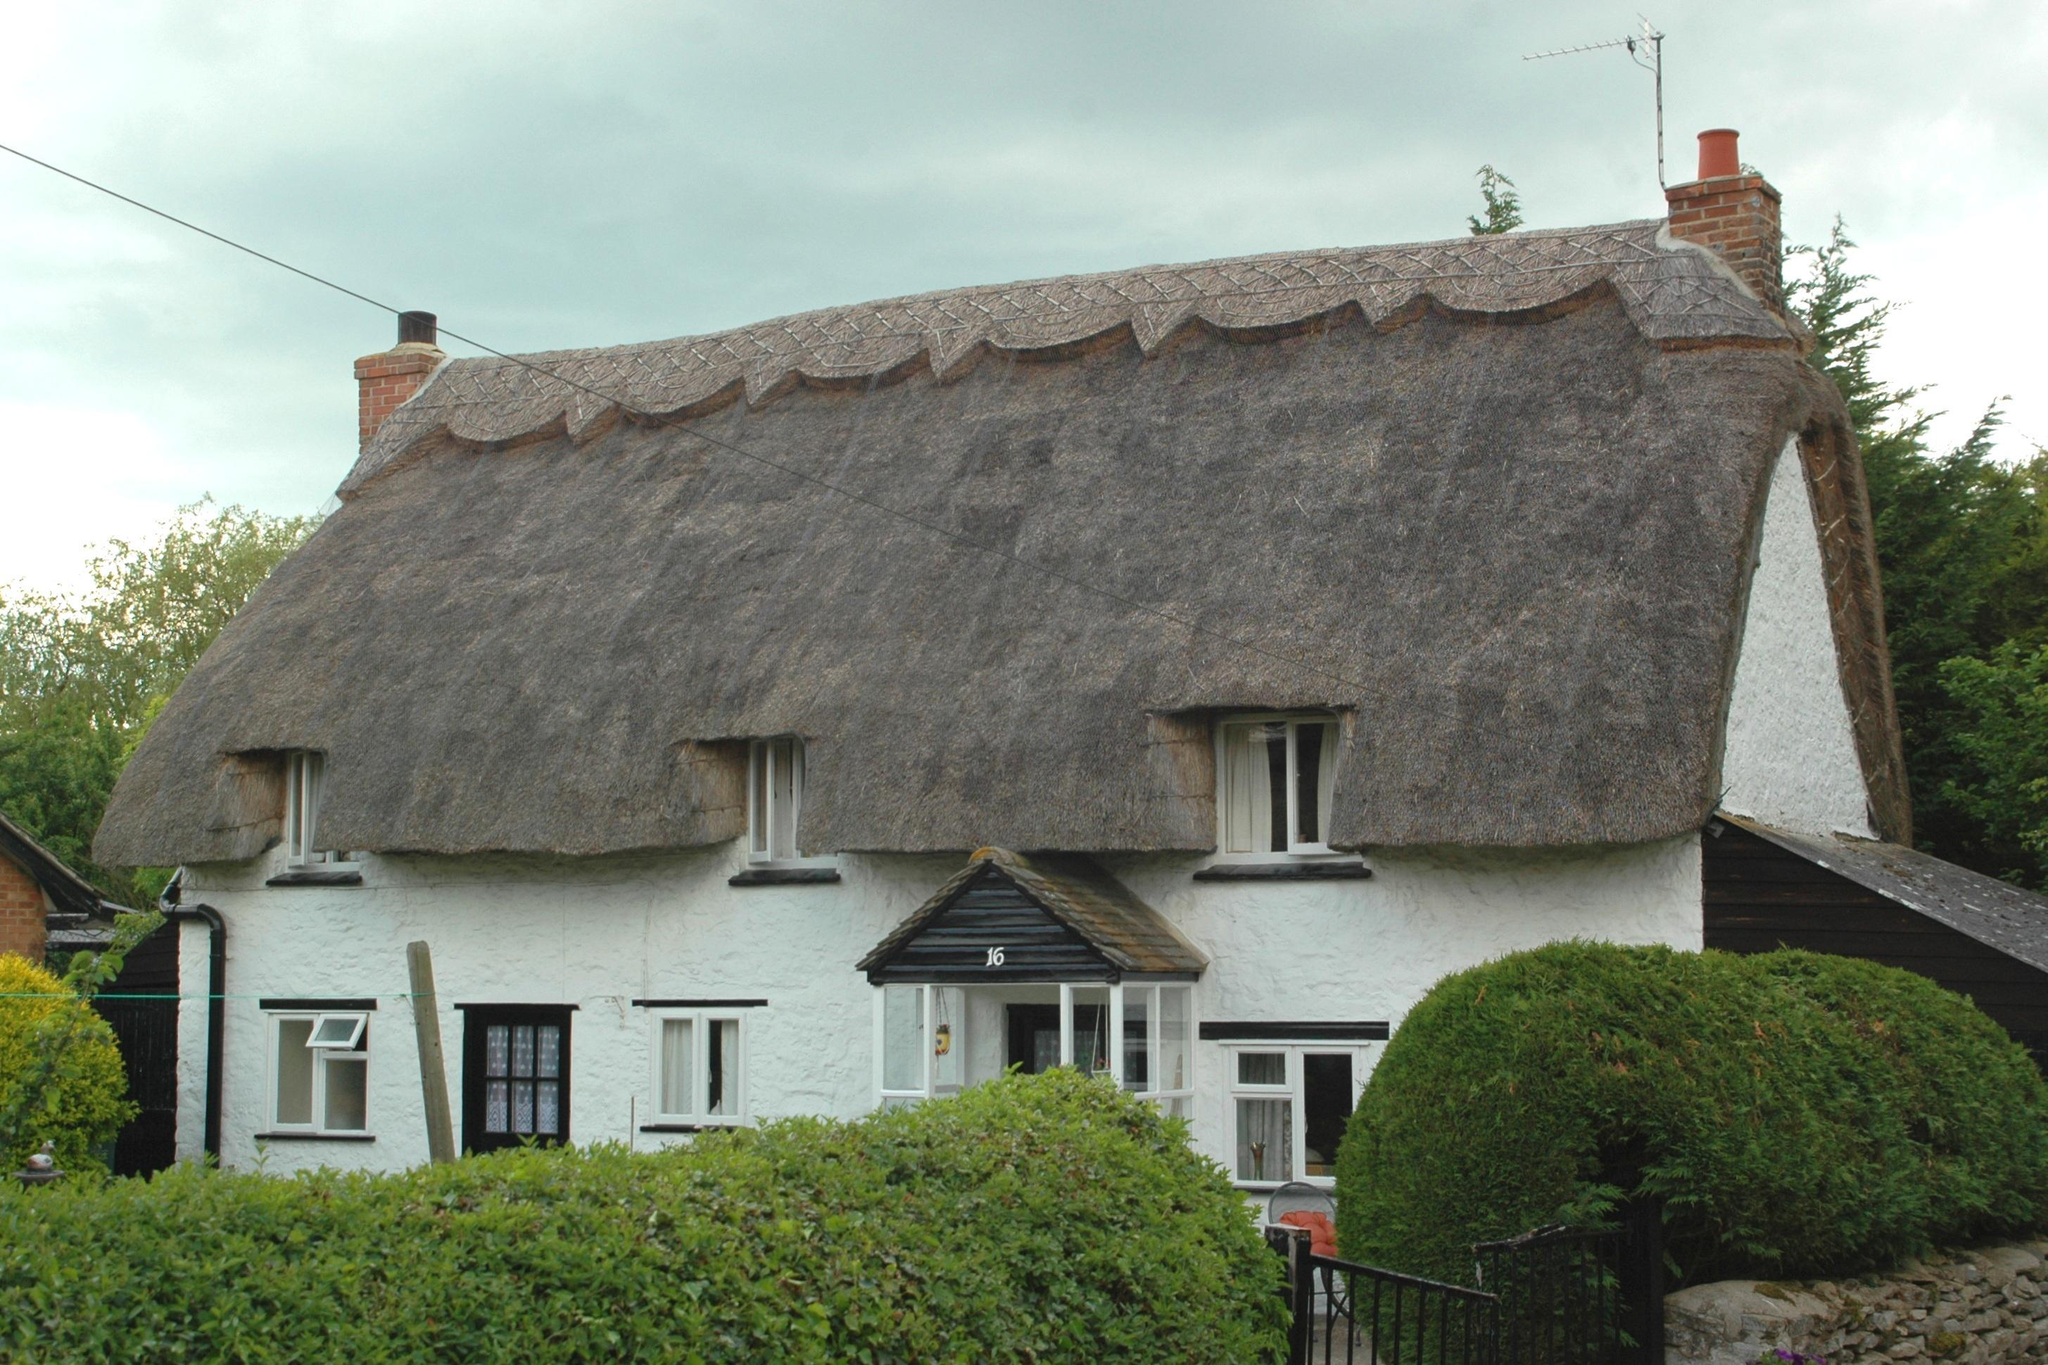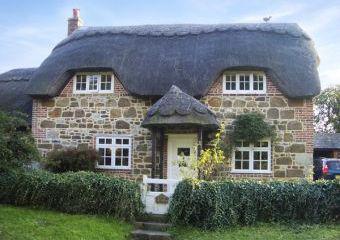The first image is the image on the left, the second image is the image on the right. Considering the images on both sides, is "The left image shows a white building with at least three notches around windows at the bottom of its gray roof, and a scalloped border along the top of the roof." valid? Answer yes or no. Yes. The first image is the image on the left, the second image is the image on the right. Evaluate the accuracy of this statement regarding the images: "There is a total of five chimneys.". Is it true? Answer yes or no. No. 